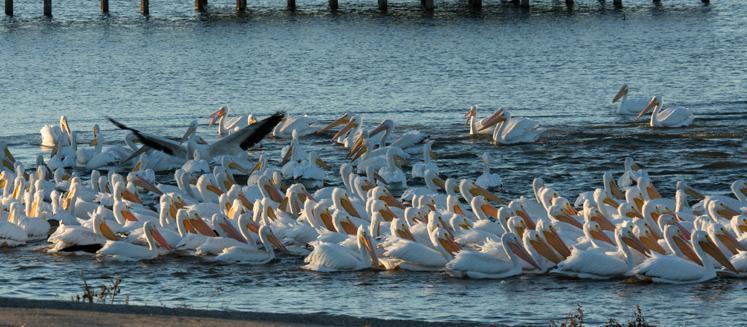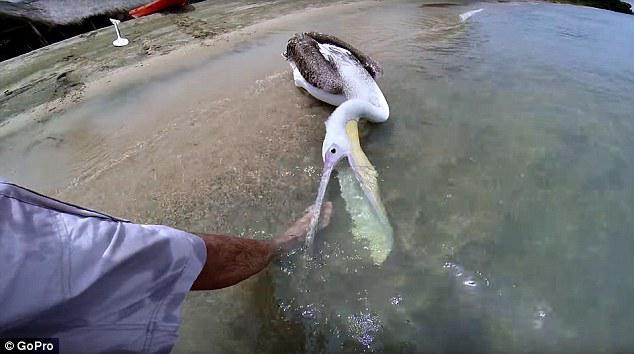The first image is the image on the left, the second image is the image on the right. Examine the images to the left and right. Is the description "One of the pelicans is opening its mouth wide." accurate? Answer yes or no. Yes. The first image is the image on the left, the second image is the image on the right. Evaluate the accuracy of this statement regarding the images: "An image shows exactly one pelican, which has a gaping mouth.". Is it true? Answer yes or no. Yes. 